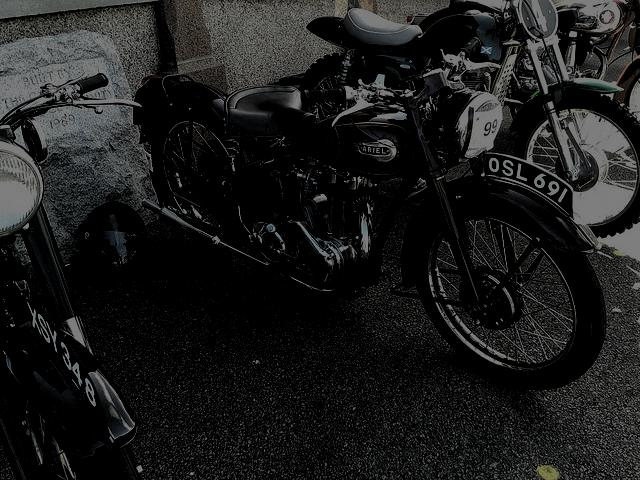Are there any quality issues with this image? The image shows a vintage motorcycle, but it's quite dark and lacks detail in the shadows, which makes it difficult to appreciate the full characteristics of the bike. Brightening the image and increasing contrast might help to bring out more details. 